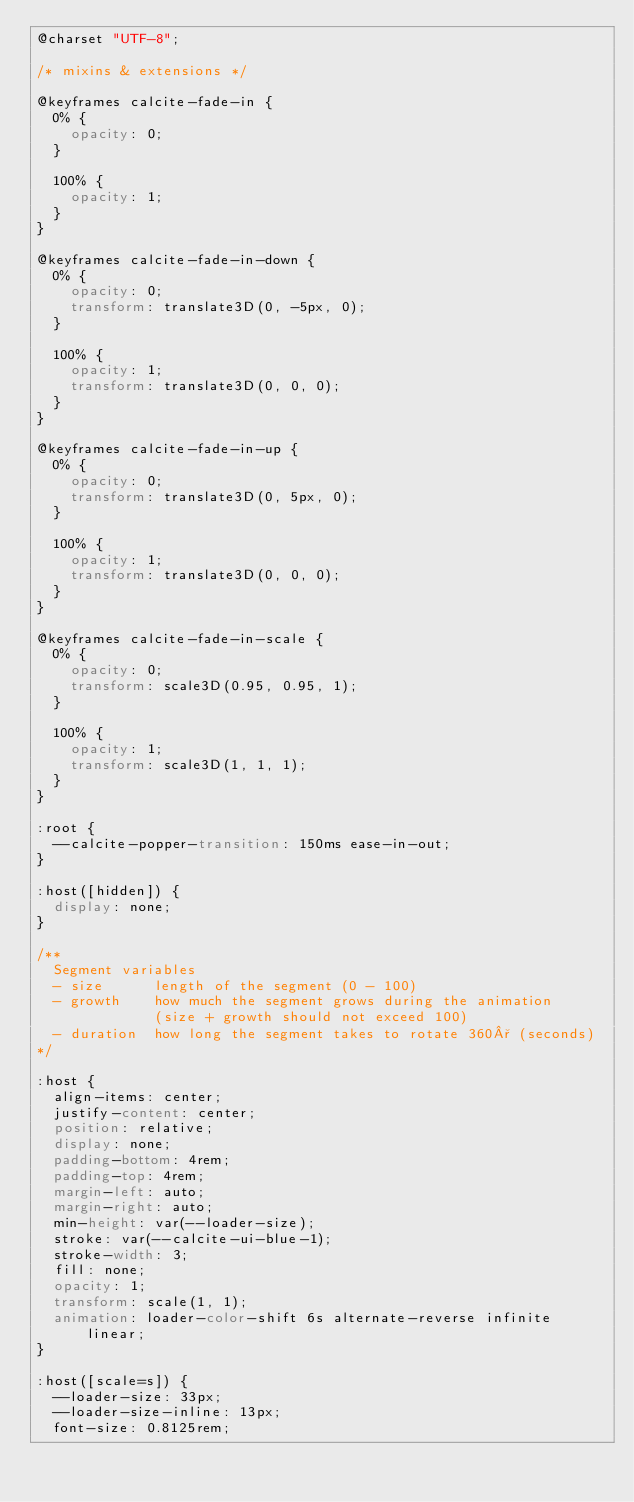<code> <loc_0><loc_0><loc_500><loc_500><_CSS_>@charset "UTF-8";

/* mixins & extensions */

@keyframes calcite-fade-in {
  0% {
    opacity: 0;
  }

  100% {
    opacity: 1;
  }
}

@keyframes calcite-fade-in-down {
  0% {
    opacity: 0;
    transform: translate3D(0, -5px, 0);
  }

  100% {
    opacity: 1;
    transform: translate3D(0, 0, 0);
  }
}

@keyframes calcite-fade-in-up {
  0% {
    opacity: 0;
    transform: translate3D(0, 5px, 0);
  }

  100% {
    opacity: 1;
    transform: translate3D(0, 0, 0);
  }
}

@keyframes calcite-fade-in-scale {
  0% {
    opacity: 0;
    transform: scale3D(0.95, 0.95, 1);
  }

  100% {
    opacity: 1;
    transform: scale3D(1, 1, 1);
  }
}

:root {
  --calcite-popper-transition: 150ms ease-in-out;
}

:host([hidden]) {
  display: none;
}

/**
  Segment variables
  - size      length of the segment (0 - 100)
  - growth    how much the segment grows during the animation
              (size + growth should not exceed 100)
  - duration  how long the segment takes to rotate 360° (seconds)
*/

:host {
  align-items: center;
  justify-content: center;
  position: relative;
  display: none;
  padding-bottom: 4rem;
  padding-top: 4rem;
  margin-left: auto;
  margin-right: auto;
  min-height: var(--loader-size);
  stroke: var(--calcite-ui-blue-1);
  stroke-width: 3;
  fill: none;
  opacity: 1;
  transform: scale(1, 1);
  animation: loader-color-shift 6s alternate-reverse infinite linear;
}

:host([scale=s]) {
  --loader-size: 33px;
  --loader-size-inline: 13px;
  font-size: 0.8125rem;</code> 